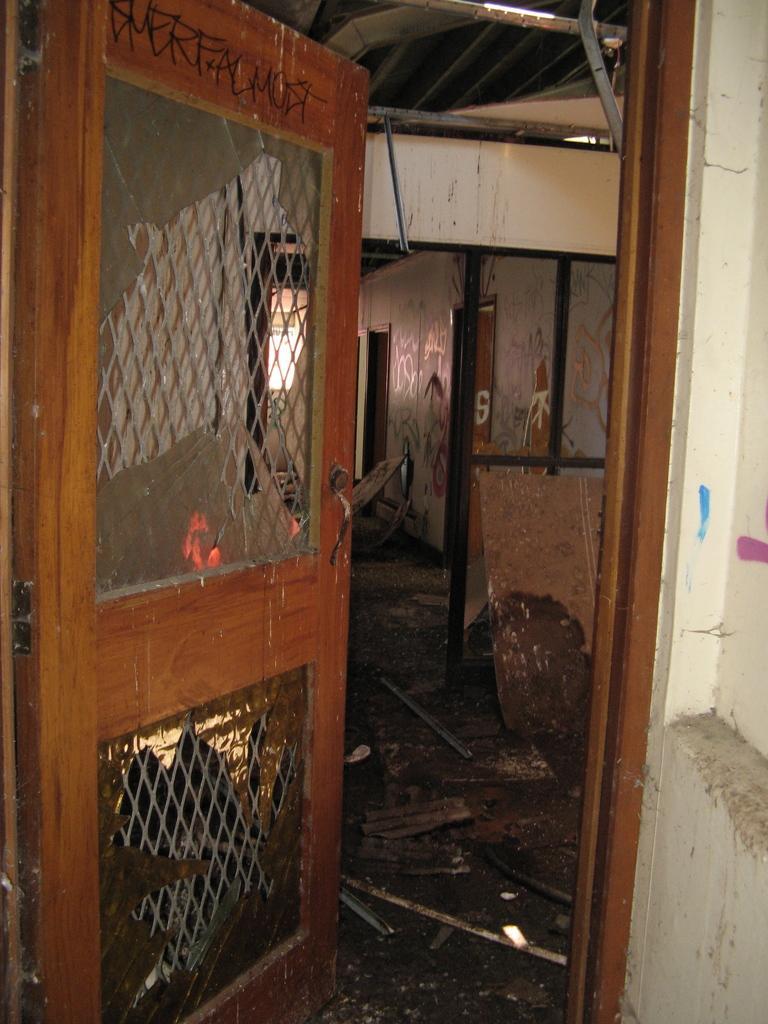What type of opening can be seen in the image? There is a door and a window in the image. What feature is present on the door and window? Iron bars are present in the image. What type of cooking appliance is visible in the image? There is a grill in the image. What type of structure is depicted in the image? There is a wall in the image. What type of earth can be seen in the image? There is no earth or soil visible in the image; it features a door, window, iron bars, a grill, and a wall. What type of statement is being made in the image? There is no statement present in the image; it is a visual representation of a door, window, iron bars, a grill, and a wall. 